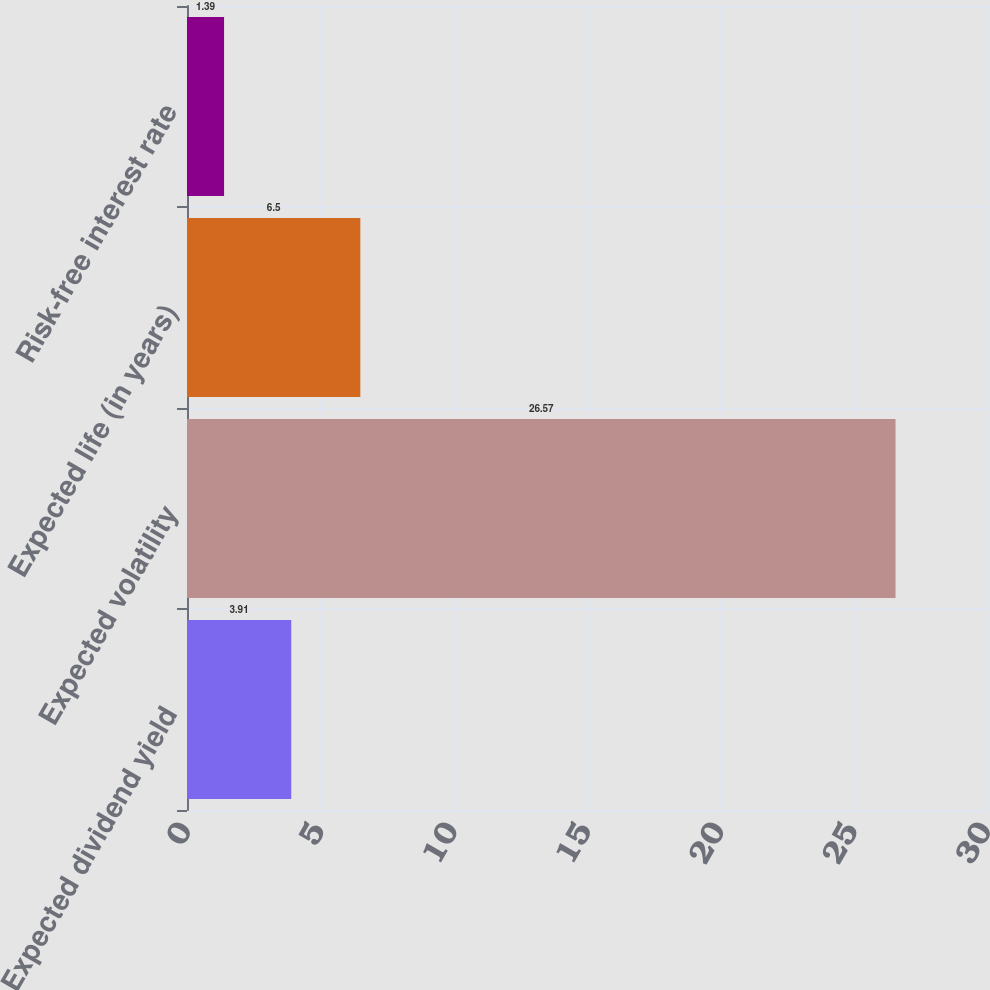<chart> <loc_0><loc_0><loc_500><loc_500><bar_chart><fcel>Expected dividend yield<fcel>Expected volatility<fcel>Expected life (in years)<fcel>Risk-free interest rate<nl><fcel>3.91<fcel>26.57<fcel>6.5<fcel>1.39<nl></chart> 